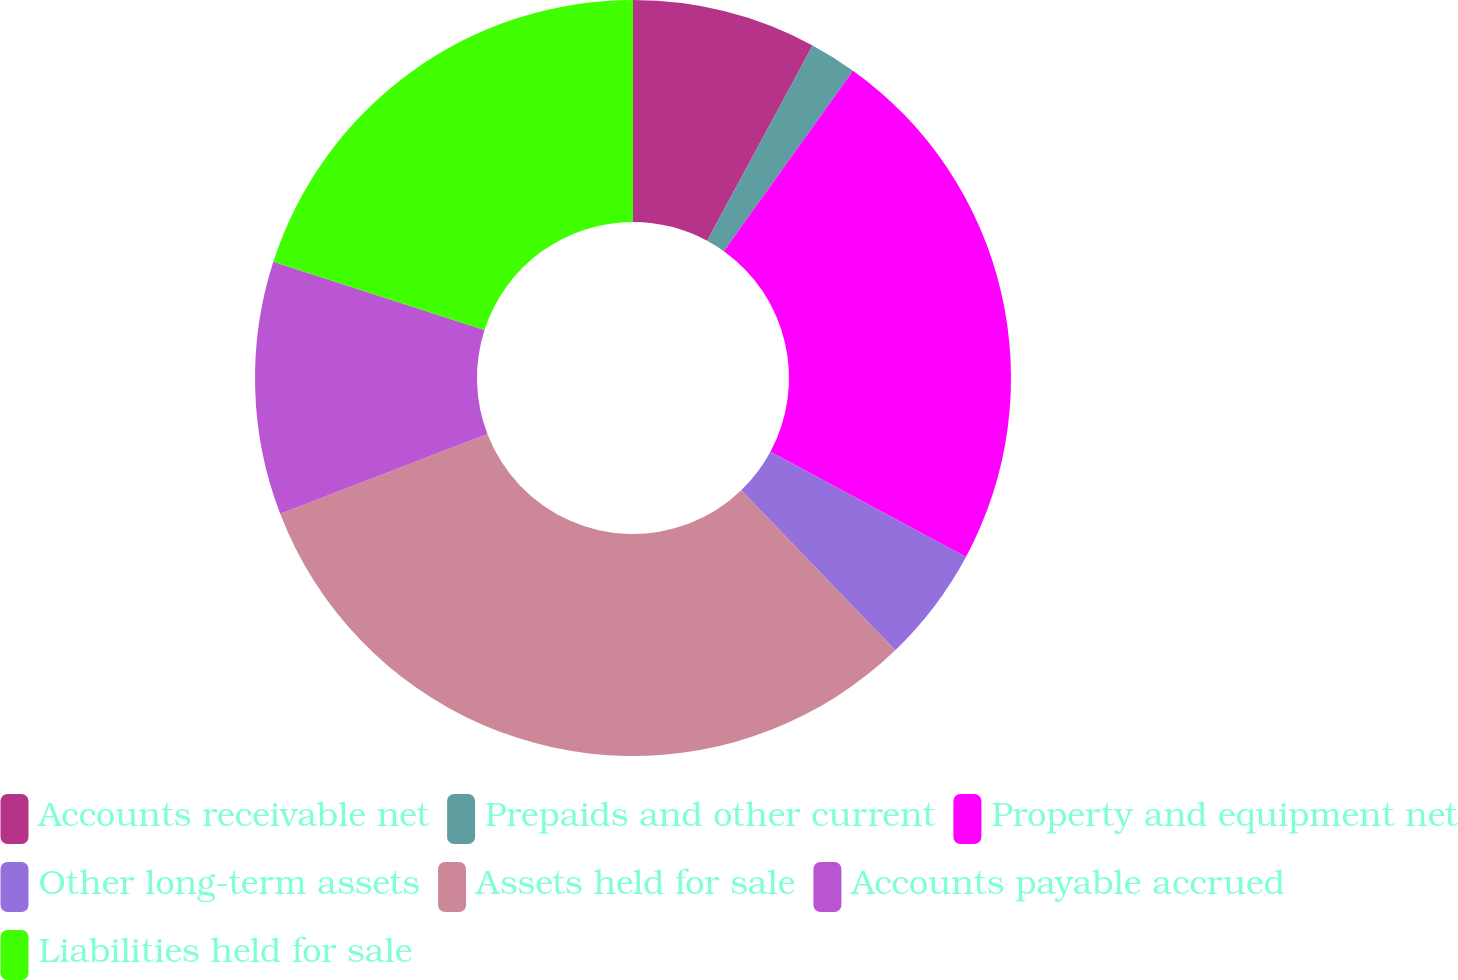<chart> <loc_0><loc_0><loc_500><loc_500><pie_chart><fcel>Accounts receivable net<fcel>Prepaids and other current<fcel>Property and equipment net<fcel>Other long-term assets<fcel>Assets held for sale<fcel>Accounts payable accrued<fcel>Liabilities held for sale<nl><fcel>7.88%<fcel>2.01%<fcel>22.96%<fcel>4.95%<fcel>31.36%<fcel>10.82%<fcel>20.03%<nl></chart> 